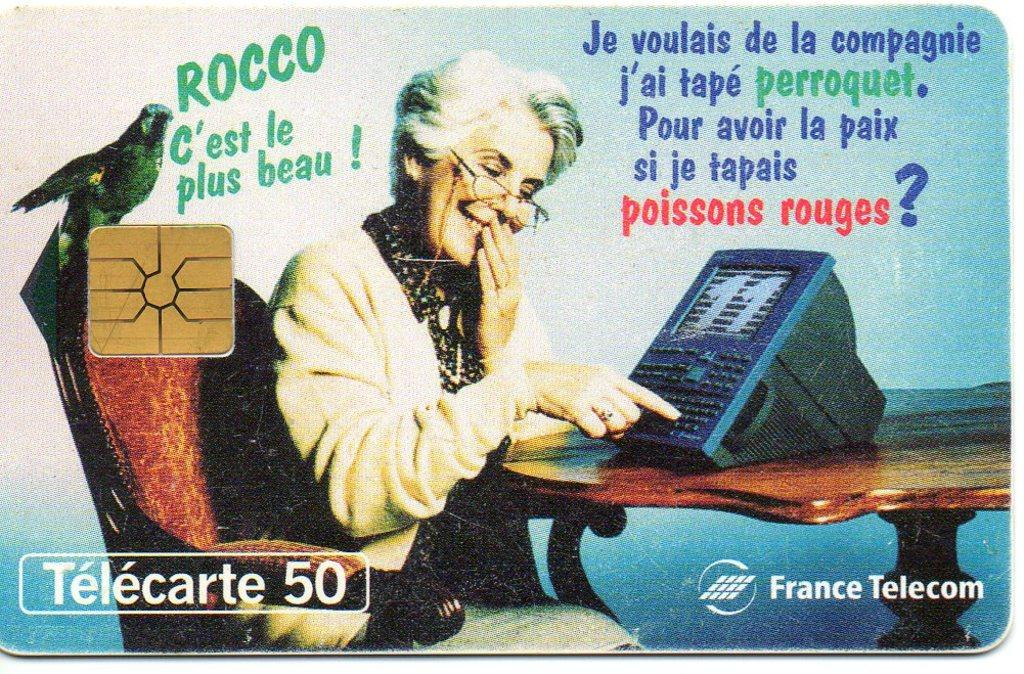What is the main subject of the card in the image? The card features a woman sitting on a chair. Are there any other elements on the card besides the woman? Yes, there is a bird depicted on the card. What can be seen on the table in the image? There is a machine on a table in the image. What is written on the card? The card contains some text. Is there any other symbol or object on the card? Yes, there is a chip shown on the card. What hobbies does the woman on the card suggest in the image? The image does not provide any information about the woman's hobbies or suggestions. 